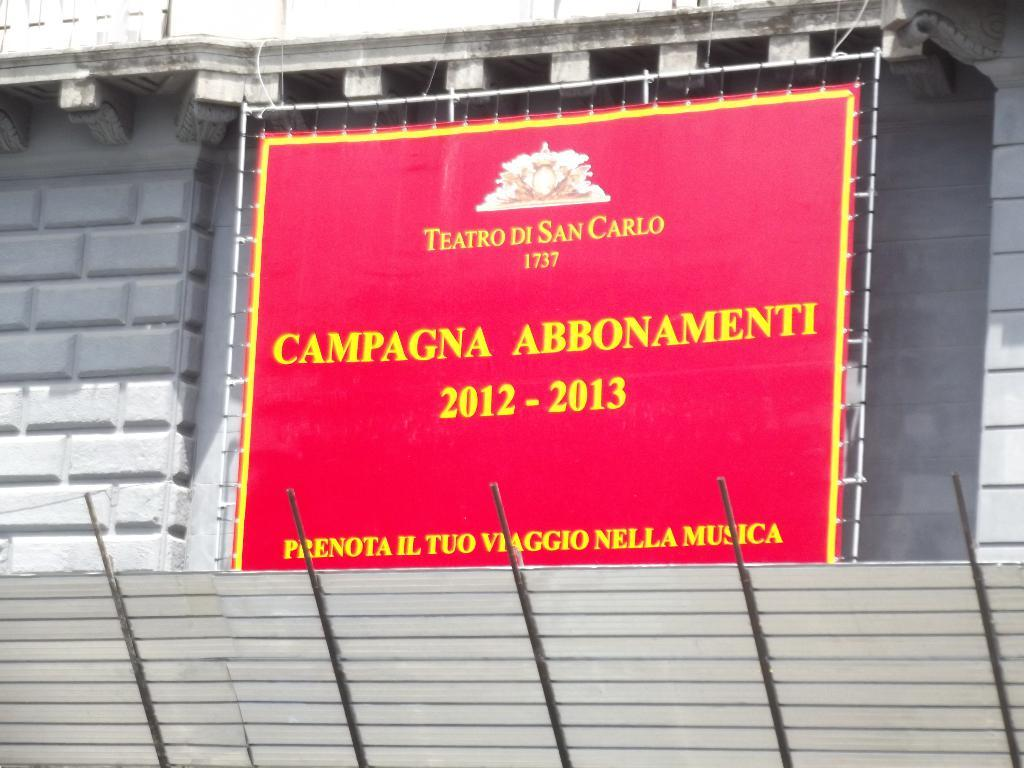What is written or displayed on the banner in the image? There is a banner with text in the image, but the specific text is not mentioned in the facts. What type of structure can be seen in the background of the image? There is a building in the background of the image. What material are the rods at the bottom of the image made of? The rods at the bottom of the image are made of metal. How many snails are crawling on the banner in the image? There are no snails present in the image. What type of bomb is visible in the background of the image? There is no bomb present in the image. 